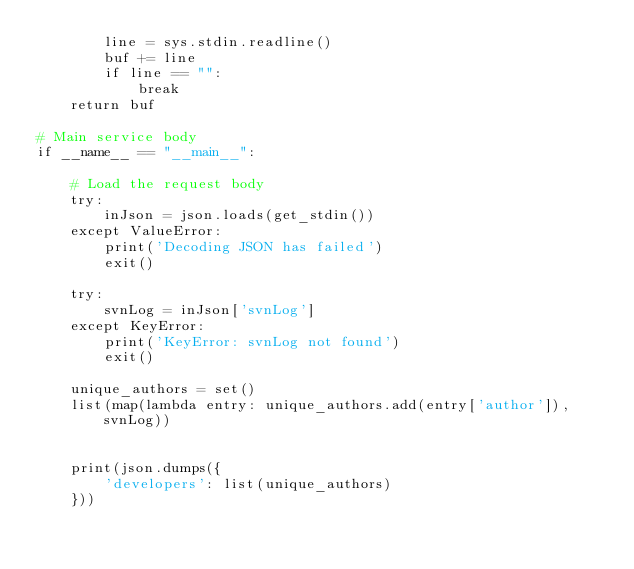Convert code to text. <code><loc_0><loc_0><loc_500><loc_500><_Python_>        line = sys.stdin.readline()
        buf += line
        if line == "":
            break
    return buf

# Main service body
if __name__ == "__main__":

    # Load the request body
    try:
        inJson = json.loads(get_stdin())
    except ValueError:
        print('Decoding JSON has failed')
        exit()

    try:
        svnLog = inJson['svnLog']
    except KeyError:
        print('KeyError: svnLog not found')
        exit()
    
    unique_authors = set()
    list(map(lambda entry: unique_authors.add(entry['author']), svnLog))

    
    print(json.dumps({
        'developers': list(unique_authors)
    }))</code> 